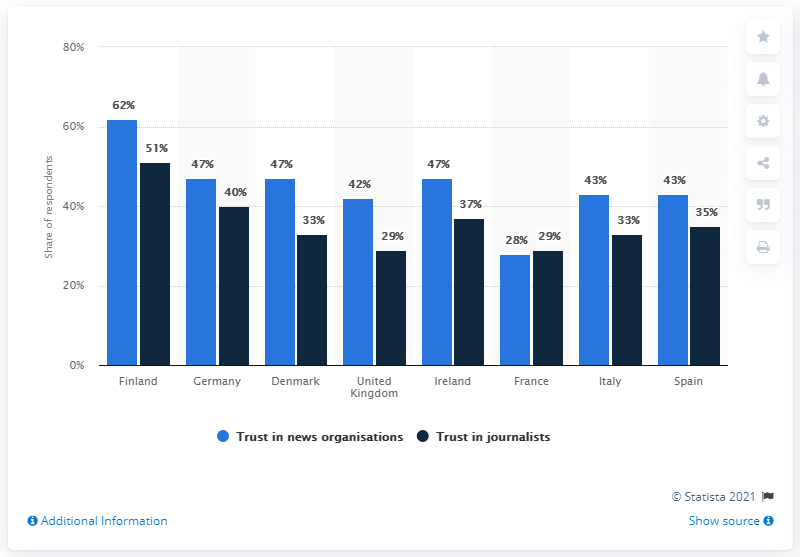Which country in this chart has the lowest trust in journalists and what might this imply? Based on the chart, Spain has the lowest trust in journalists, with only 35% of the respondents indicating trust. This could imply challenges in journalistic practices, public perception of media bias, or broader social and political issues affecting the trustworthiness of journalists in the eyes of the Spanish public. 